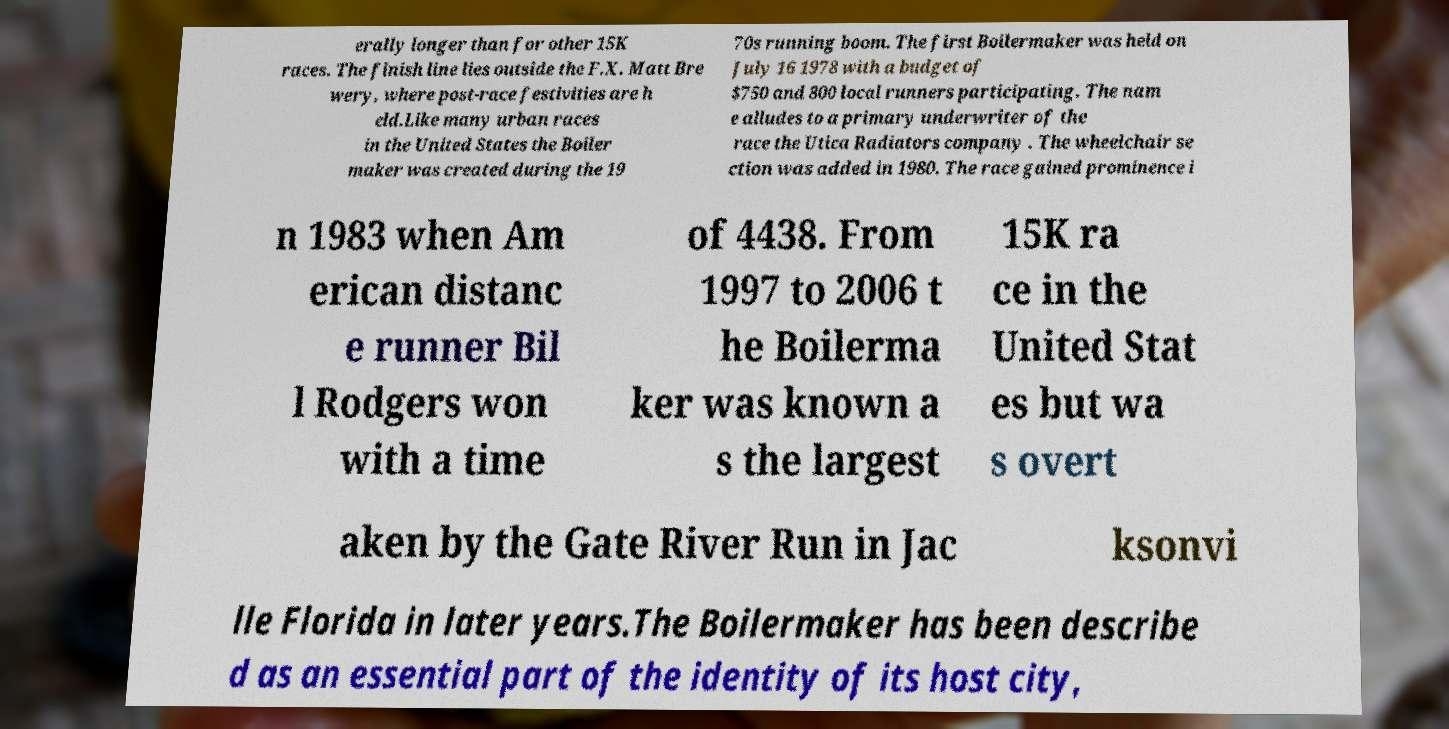Can you accurately transcribe the text from the provided image for me? erally longer than for other 15K races. The finish line lies outside the F.X. Matt Bre wery, where post-race festivities are h eld.Like many urban races in the United States the Boiler maker was created during the 19 70s running boom. The first Boilermaker was held on July 16 1978 with a budget of $750 and 800 local runners participating. The nam e alludes to a primary underwriter of the race the Utica Radiators company . The wheelchair se ction was added in 1980. The race gained prominence i n 1983 when Am erican distanc e runner Bil l Rodgers won with a time of 4438. From 1997 to 2006 t he Boilerma ker was known a s the largest 15K ra ce in the United Stat es but wa s overt aken by the Gate River Run in Jac ksonvi lle Florida in later years.The Boilermaker has been describe d as an essential part of the identity of its host city, 